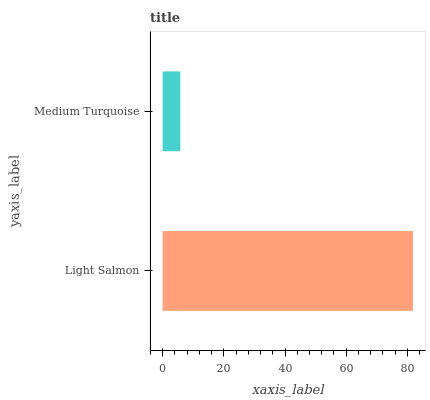Is Medium Turquoise the minimum?
Answer yes or no. Yes. Is Light Salmon the maximum?
Answer yes or no. Yes. Is Medium Turquoise the maximum?
Answer yes or no. No. Is Light Salmon greater than Medium Turquoise?
Answer yes or no. Yes. Is Medium Turquoise less than Light Salmon?
Answer yes or no. Yes. Is Medium Turquoise greater than Light Salmon?
Answer yes or no. No. Is Light Salmon less than Medium Turquoise?
Answer yes or no. No. Is Light Salmon the high median?
Answer yes or no. Yes. Is Medium Turquoise the low median?
Answer yes or no. Yes. Is Medium Turquoise the high median?
Answer yes or no. No. Is Light Salmon the low median?
Answer yes or no. No. 